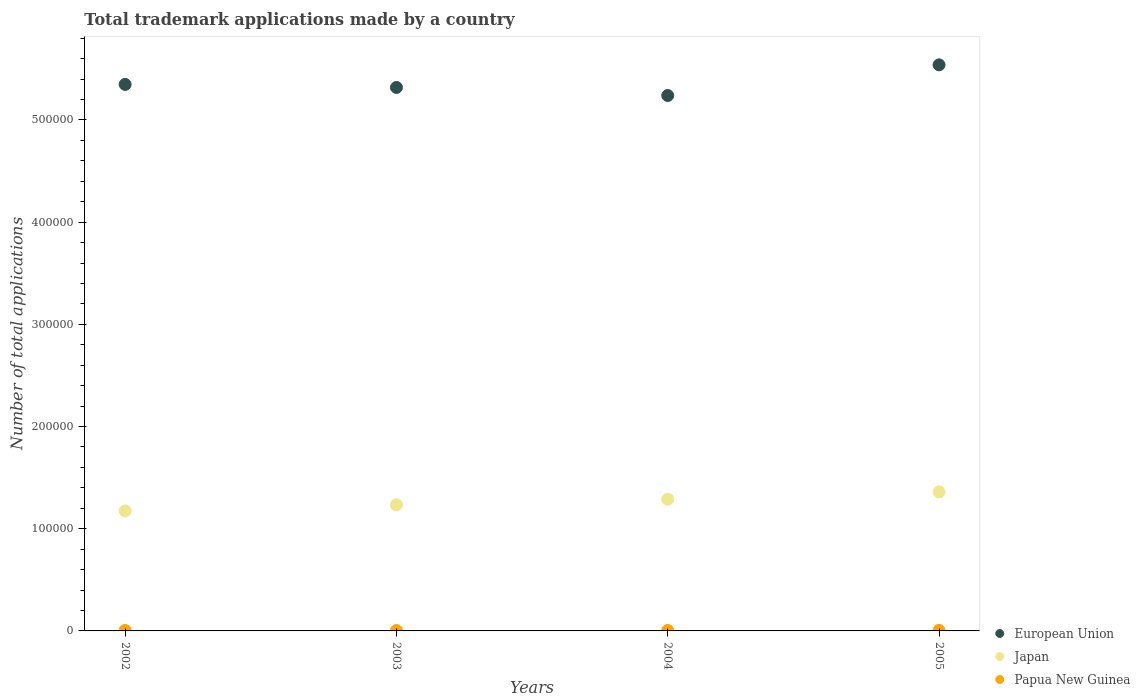What is the number of applications made by in Papua New Guinea in 2003?
Provide a succinct answer. 399. Across all years, what is the maximum number of applications made by in Japan?
Provide a short and direct response. 1.36e+05. Across all years, what is the minimum number of applications made by in European Union?
Your response must be concise. 5.24e+05. In which year was the number of applications made by in Japan minimum?
Your response must be concise. 2002. What is the total number of applications made by in European Union in the graph?
Keep it short and to the point. 2.14e+06. What is the difference between the number of applications made by in Papua New Guinea in 2003 and that in 2004?
Your response must be concise. -68. What is the difference between the number of applications made by in European Union in 2004 and the number of applications made by in Japan in 2003?
Give a very brief answer. 4.01e+05. What is the average number of applications made by in Papua New Guinea per year?
Your answer should be compact. 460.75. In the year 2005, what is the difference between the number of applications made by in Papua New Guinea and number of applications made by in Japan?
Give a very brief answer. -1.36e+05. What is the ratio of the number of applications made by in Papua New Guinea in 2002 to that in 2005?
Offer a very short reply. 0.89. Is the number of applications made by in Papua New Guinea in 2003 less than that in 2005?
Give a very brief answer. Yes. What is the difference between the highest and the second highest number of applications made by in Papua New Guinea?
Make the answer very short. 50. What is the difference between the highest and the lowest number of applications made by in Papua New Guinea?
Keep it short and to the point. 118. In how many years, is the number of applications made by in Japan greater than the average number of applications made by in Japan taken over all years?
Offer a very short reply. 2. Is the sum of the number of applications made by in European Union in 2002 and 2005 greater than the maximum number of applications made by in Japan across all years?
Offer a very short reply. Yes. Is it the case that in every year, the sum of the number of applications made by in Japan and number of applications made by in European Union  is greater than the number of applications made by in Papua New Guinea?
Provide a succinct answer. Yes. Does the number of applications made by in European Union monotonically increase over the years?
Offer a very short reply. No. How many years are there in the graph?
Your answer should be very brief. 4. What is the difference between two consecutive major ticks on the Y-axis?
Provide a short and direct response. 1.00e+05. Are the values on the major ticks of Y-axis written in scientific E-notation?
Your answer should be compact. No. Where does the legend appear in the graph?
Provide a succinct answer. Bottom right. How many legend labels are there?
Keep it short and to the point. 3. How are the legend labels stacked?
Keep it short and to the point. Vertical. What is the title of the graph?
Provide a short and direct response. Total trademark applications made by a country. What is the label or title of the Y-axis?
Keep it short and to the point. Number of total applications. What is the Number of total applications of European Union in 2002?
Provide a succinct answer. 5.35e+05. What is the Number of total applications in Japan in 2002?
Offer a terse response. 1.17e+05. What is the Number of total applications in Papua New Guinea in 2002?
Keep it short and to the point. 460. What is the Number of total applications of European Union in 2003?
Your answer should be very brief. 5.32e+05. What is the Number of total applications of Japan in 2003?
Your answer should be very brief. 1.23e+05. What is the Number of total applications in Papua New Guinea in 2003?
Provide a short and direct response. 399. What is the Number of total applications in European Union in 2004?
Offer a very short reply. 5.24e+05. What is the Number of total applications of Japan in 2004?
Keep it short and to the point. 1.29e+05. What is the Number of total applications of Papua New Guinea in 2004?
Your response must be concise. 467. What is the Number of total applications of European Union in 2005?
Make the answer very short. 5.54e+05. What is the Number of total applications of Japan in 2005?
Ensure brevity in your answer.  1.36e+05. What is the Number of total applications of Papua New Guinea in 2005?
Keep it short and to the point. 517. Across all years, what is the maximum Number of total applications in European Union?
Offer a terse response. 5.54e+05. Across all years, what is the maximum Number of total applications of Japan?
Your response must be concise. 1.36e+05. Across all years, what is the maximum Number of total applications in Papua New Guinea?
Offer a terse response. 517. Across all years, what is the minimum Number of total applications of European Union?
Ensure brevity in your answer.  5.24e+05. Across all years, what is the minimum Number of total applications in Japan?
Offer a terse response. 1.17e+05. Across all years, what is the minimum Number of total applications in Papua New Guinea?
Ensure brevity in your answer.  399. What is the total Number of total applications in European Union in the graph?
Keep it short and to the point. 2.14e+06. What is the total Number of total applications in Japan in the graph?
Give a very brief answer. 5.06e+05. What is the total Number of total applications in Papua New Guinea in the graph?
Ensure brevity in your answer.  1843. What is the difference between the Number of total applications in European Union in 2002 and that in 2003?
Offer a very short reply. 2980. What is the difference between the Number of total applications in Japan in 2002 and that in 2003?
Provide a succinct answer. -5921. What is the difference between the Number of total applications of Papua New Guinea in 2002 and that in 2003?
Give a very brief answer. 61. What is the difference between the Number of total applications in European Union in 2002 and that in 2004?
Offer a terse response. 1.09e+04. What is the difference between the Number of total applications in Japan in 2002 and that in 2004?
Your answer should be very brief. -1.14e+04. What is the difference between the Number of total applications in European Union in 2002 and that in 2005?
Provide a short and direct response. -1.91e+04. What is the difference between the Number of total applications of Japan in 2002 and that in 2005?
Give a very brief answer. -1.86e+04. What is the difference between the Number of total applications of Papua New Guinea in 2002 and that in 2005?
Provide a short and direct response. -57. What is the difference between the Number of total applications in European Union in 2003 and that in 2004?
Your answer should be compact. 7892. What is the difference between the Number of total applications of Japan in 2003 and that in 2004?
Provide a succinct answer. -5458. What is the difference between the Number of total applications in Papua New Guinea in 2003 and that in 2004?
Offer a terse response. -68. What is the difference between the Number of total applications in European Union in 2003 and that in 2005?
Your answer should be very brief. -2.21e+04. What is the difference between the Number of total applications in Japan in 2003 and that in 2005?
Offer a terse response. -1.27e+04. What is the difference between the Number of total applications of Papua New Guinea in 2003 and that in 2005?
Provide a succinct answer. -118. What is the difference between the Number of total applications in European Union in 2004 and that in 2005?
Keep it short and to the point. -3.00e+04. What is the difference between the Number of total applications in Japan in 2004 and that in 2005?
Keep it short and to the point. -7199. What is the difference between the Number of total applications in Papua New Guinea in 2004 and that in 2005?
Your answer should be very brief. -50. What is the difference between the Number of total applications in European Union in 2002 and the Number of total applications in Japan in 2003?
Offer a very short reply. 4.11e+05. What is the difference between the Number of total applications in European Union in 2002 and the Number of total applications in Papua New Guinea in 2003?
Ensure brevity in your answer.  5.34e+05. What is the difference between the Number of total applications of Japan in 2002 and the Number of total applications of Papua New Guinea in 2003?
Make the answer very short. 1.17e+05. What is the difference between the Number of total applications in European Union in 2002 and the Number of total applications in Japan in 2004?
Provide a succinct answer. 4.06e+05. What is the difference between the Number of total applications in European Union in 2002 and the Number of total applications in Papua New Guinea in 2004?
Ensure brevity in your answer.  5.34e+05. What is the difference between the Number of total applications of Japan in 2002 and the Number of total applications of Papua New Guinea in 2004?
Give a very brief answer. 1.17e+05. What is the difference between the Number of total applications in European Union in 2002 and the Number of total applications in Japan in 2005?
Provide a succinct answer. 3.99e+05. What is the difference between the Number of total applications in European Union in 2002 and the Number of total applications in Papua New Guinea in 2005?
Make the answer very short. 5.34e+05. What is the difference between the Number of total applications in Japan in 2002 and the Number of total applications in Papua New Guinea in 2005?
Your answer should be very brief. 1.17e+05. What is the difference between the Number of total applications in European Union in 2003 and the Number of total applications in Japan in 2004?
Keep it short and to the point. 4.03e+05. What is the difference between the Number of total applications in European Union in 2003 and the Number of total applications in Papua New Guinea in 2004?
Make the answer very short. 5.31e+05. What is the difference between the Number of total applications in Japan in 2003 and the Number of total applications in Papua New Guinea in 2004?
Provide a short and direct response. 1.23e+05. What is the difference between the Number of total applications of European Union in 2003 and the Number of total applications of Japan in 2005?
Keep it short and to the point. 3.96e+05. What is the difference between the Number of total applications in European Union in 2003 and the Number of total applications in Papua New Guinea in 2005?
Your response must be concise. 5.31e+05. What is the difference between the Number of total applications of Japan in 2003 and the Number of total applications of Papua New Guinea in 2005?
Your response must be concise. 1.23e+05. What is the difference between the Number of total applications of European Union in 2004 and the Number of total applications of Japan in 2005?
Ensure brevity in your answer.  3.88e+05. What is the difference between the Number of total applications of European Union in 2004 and the Number of total applications of Papua New Guinea in 2005?
Your response must be concise. 5.23e+05. What is the difference between the Number of total applications in Japan in 2004 and the Number of total applications in Papua New Guinea in 2005?
Ensure brevity in your answer.  1.28e+05. What is the average Number of total applications in European Union per year?
Give a very brief answer. 5.36e+05. What is the average Number of total applications of Japan per year?
Offer a terse response. 1.26e+05. What is the average Number of total applications of Papua New Guinea per year?
Offer a very short reply. 460.75. In the year 2002, what is the difference between the Number of total applications of European Union and Number of total applications of Japan?
Your answer should be compact. 4.17e+05. In the year 2002, what is the difference between the Number of total applications in European Union and Number of total applications in Papua New Guinea?
Provide a succinct answer. 5.34e+05. In the year 2002, what is the difference between the Number of total applications in Japan and Number of total applications in Papua New Guinea?
Provide a succinct answer. 1.17e+05. In the year 2003, what is the difference between the Number of total applications in European Union and Number of total applications in Japan?
Make the answer very short. 4.08e+05. In the year 2003, what is the difference between the Number of total applications of European Union and Number of total applications of Papua New Guinea?
Your response must be concise. 5.31e+05. In the year 2003, what is the difference between the Number of total applications of Japan and Number of total applications of Papua New Guinea?
Offer a very short reply. 1.23e+05. In the year 2004, what is the difference between the Number of total applications in European Union and Number of total applications in Japan?
Make the answer very short. 3.95e+05. In the year 2004, what is the difference between the Number of total applications in European Union and Number of total applications in Papua New Guinea?
Keep it short and to the point. 5.23e+05. In the year 2004, what is the difference between the Number of total applications in Japan and Number of total applications in Papua New Guinea?
Offer a terse response. 1.28e+05. In the year 2005, what is the difference between the Number of total applications of European Union and Number of total applications of Japan?
Your answer should be very brief. 4.18e+05. In the year 2005, what is the difference between the Number of total applications in European Union and Number of total applications in Papua New Guinea?
Provide a short and direct response. 5.53e+05. In the year 2005, what is the difference between the Number of total applications in Japan and Number of total applications in Papua New Guinea?
Provide a short and direct response. 1.36e+05. What is the ratio of the Number of total applications of European Union in 2002 to that in 2003?
Make the answer very short. 1.01. What is the ratio of the Number of total applications of Papua New Guinea in 2002 to that in 2003?
Keep it short and to the point. 1.15. What is the ratio of the Number of total applications of European Union in 2002 to that in 2004?
Ensure brevity in your answer.  1.02. What is the ratio of the Number of total applications in Japan in 2002 to that in 2004?
Your answer should be compact. 0.91. What is the ratio of the Number of total applications of European Union in 2002 to that in 2005?
Your answer should be very brief. 0.97. What is the ratio of the Number of total applications of Japan in 2002 to that in 2005?
Offer a terse response. 0.86. What is the ratio of the Number of total applications of Papua New Guinea in 2002 to that in 2005?
Provide a succinct answer. 0.89. What is the ratio of the Number of total applications in European Union in 2003 to that in 2004?
Your response must be concise. 1.02. What is the ratio of the Number of total applications in Japan in 2003 to that in 2004?
Offer a terse response. 0.96. What is the ratio of the Number of total applications in Papua New Guinea in 2003 to that in 2004?
Make the answer very short. 0.85. What is the ratio of the Number of total applications in European Union in 2003 to that in 2005?
Offer a very short reply. 0.96. What is the ratio of the Number of total applications of Japan in 2003 to that in 2005?
Give a very brief answer. 0.91. What is the ratio of the Number of total applications in Papua New Guinea in 2003 to that in 2005?
Provide a succinct answer. 0.77. What is the ratio of the Number of total applications of European Union in 2004 to that in 2005?
Your answer should be very brief. 0.95. What is the ratio of the Number of total applications of Japan in 2004 to that in 2005?
Make the answer very short. 0.95. What is the ratio of the Number of total applications in Papua New Guinea in 2004 to that in 2005?
Offer a very short reply. 0.9. What is the difference between the highest and the second highest Number of total applications of European Union?
Your response must be concise. 1.91e+04. What is the difference between the highest and the second highest Number of total applications of Japan?
Offer a very short reply. 7199. What is the difference between the highest and the second highest Number of total applications in Papua New Guinea?
Keep it short and to the point. 50. What is the difference between the highest and the lowest Number of total applications of European Union?
Ensure brevity in your answer.  3.00e+04. What is the difference between the highest and the lowest Number of total applications in Japan?
Your response must be concise. 1.86e+04. What is the difference between the highest and the lowest Number of total applications in Papua New Guinea?
Provide a short and direct response. 118. 